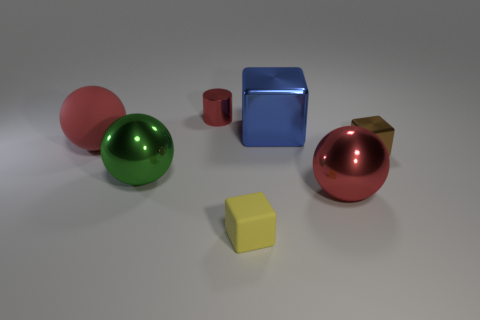The metallic thing that is the same color as the shiny cylinder is what shape?
Provide a succinct answer. Sphere. How many large things are there?
Offer a very short reply. 4. What shape is the small red metallic thing?
Provide a succinct answer. Cylinder. What number of green shiny things have the same size as the red matte thing?
Give a very brief answer. 1. Does the tiny red thing have the same shape as the yellow thing?
Your answer should be very brief. No. What color is the cube that is in front of the red object in front of the brown thing?
Your answer should be compact. Yellow. There is a object that is on the left side of the large red metal object and right of the matte block; what size is it?
Provide a succinct answer. Large. Is there anything else that is the same color as the big rubber object?
Your response must be concise. Yes. What is the shape of the brown object that is made of the same material as the green thing?
Ensure brevity in your answer.  Cube. Is the shape of the green shiny object the same as the red metallic thing that is in front of the big metal block?
Give a very brief answer. Yes. 